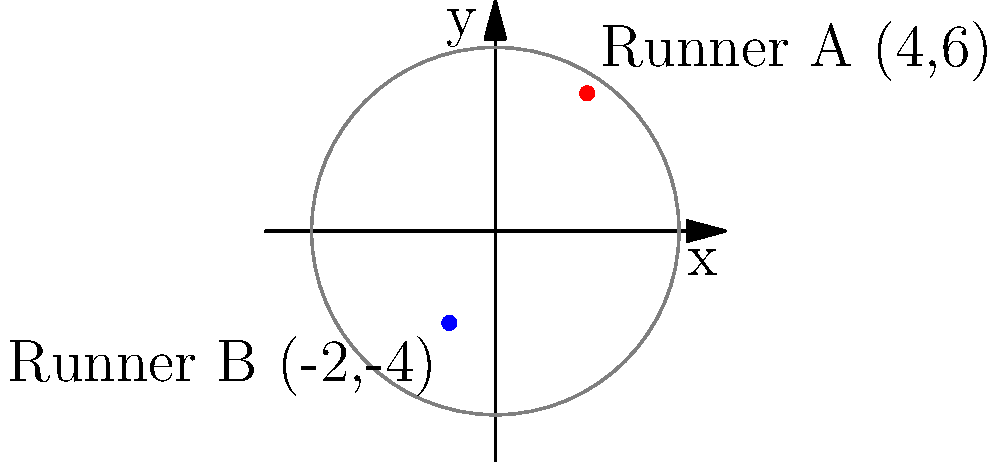In a traditional track and field event, two runners are positioned at different points on a circular track. Runner A is at coordinate $(4,6)$, while Runner B is at $(-2,-4)$. To ensure fair officiating, a referee needs to position himself at the midpoint between these two runners. What are the coordinates of this midpoint where the referee should stand? To find the midpoint between two points, we use the midpoint formula:

$$ \text{Midpoint} = \left(\frac{x_1 + x_2}{2}, \frac{y_1 + y_2}{2}\right) $$

Where $(x_1, y_1)$ are the coordinates of the first point and $(x_2, y_2)$ are the coordinates of the second point.

Let's apply this formula to our scenario:

1. Runner A's coordinates: $(x_1, y_1) = (4, 6)$
2. Runner B's coordinates: $(x_2, y_2) = (-2, -4)$

Now, let's calculate the x-coordinate of the midpoint:
$$ x = \frac{x_1 + x_2}{2} = \frac{4 + (-2)}{2} = \frac{2}{2} = 1 $$

Next, let's calculate the y-coordinate of the midpoint:
$$ y = \frac{y_1 + y_2}{2} = \frac{6 + (-4)}{2} = \frac{2}{2} = 1 $$

Therefore, the midpoint coordinates where the referee should stand are $(1, 1)$.
Answer: $(1, 1)$ 